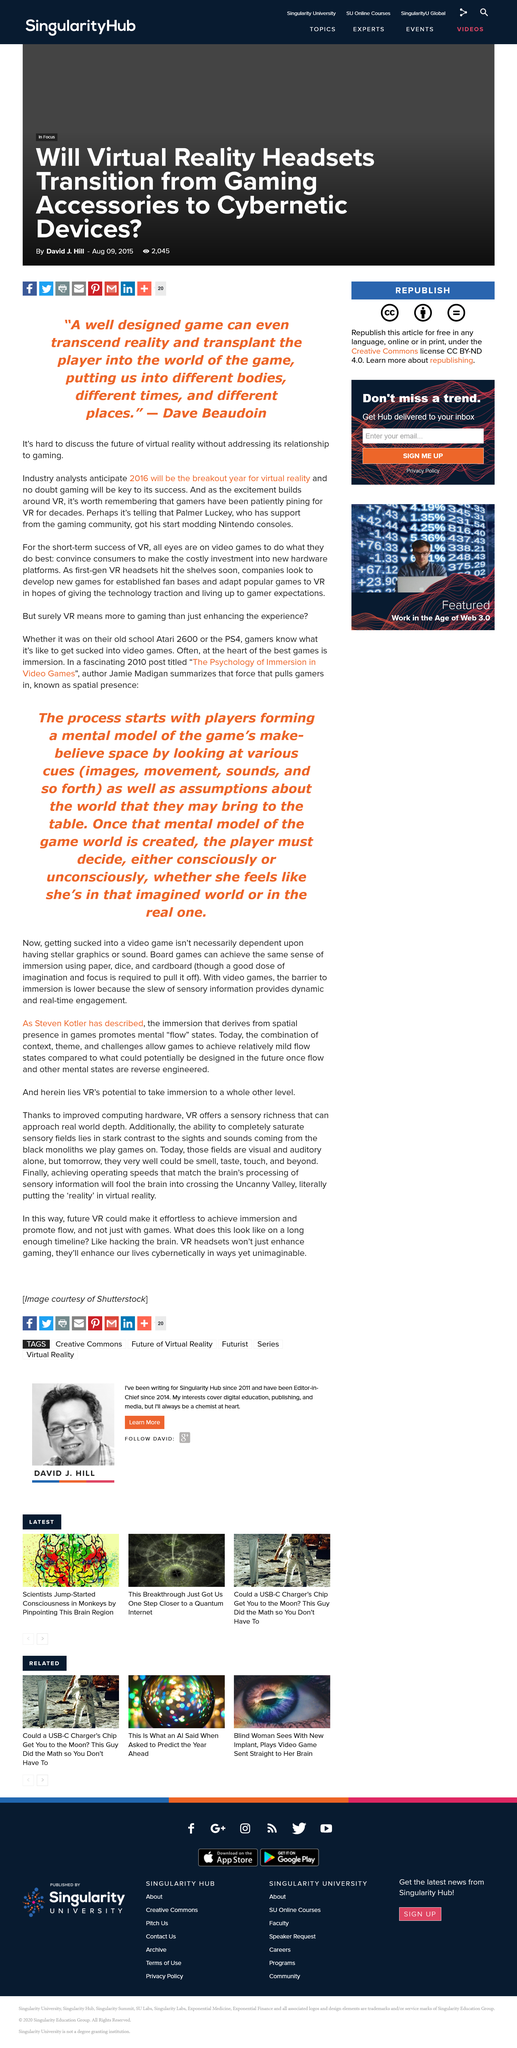Identify some key points in this picture. Which year will be the breakout year? I believe it will be 2016. The abbreviation VR is used a total of 6 times. Dave's second name is Beaudoin. 